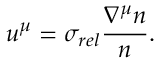Convert formula to latex. <formula><loc_0><loc_0><loc_500><loc_500>u ^ { \mu } = \sigma _ { r e l } \frac { \nabla ^ { \mu } n } { n } .</formula> 